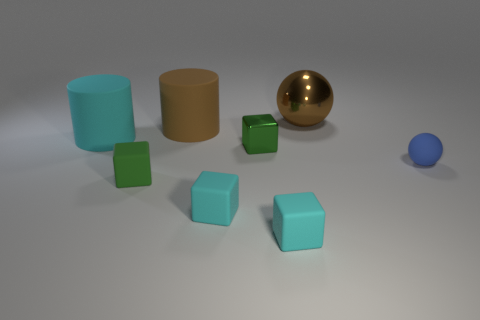Is the color of the small shiny object the same as the small rubber object that is behind the small green rubber thing? No, the small shiny object, which appears to be a gold-colored sphere, is not the same color as the small rubber object behind the green rubber cube. That object has a brownish tone, distinctly different from the metallic gold of the shiny sphere. 